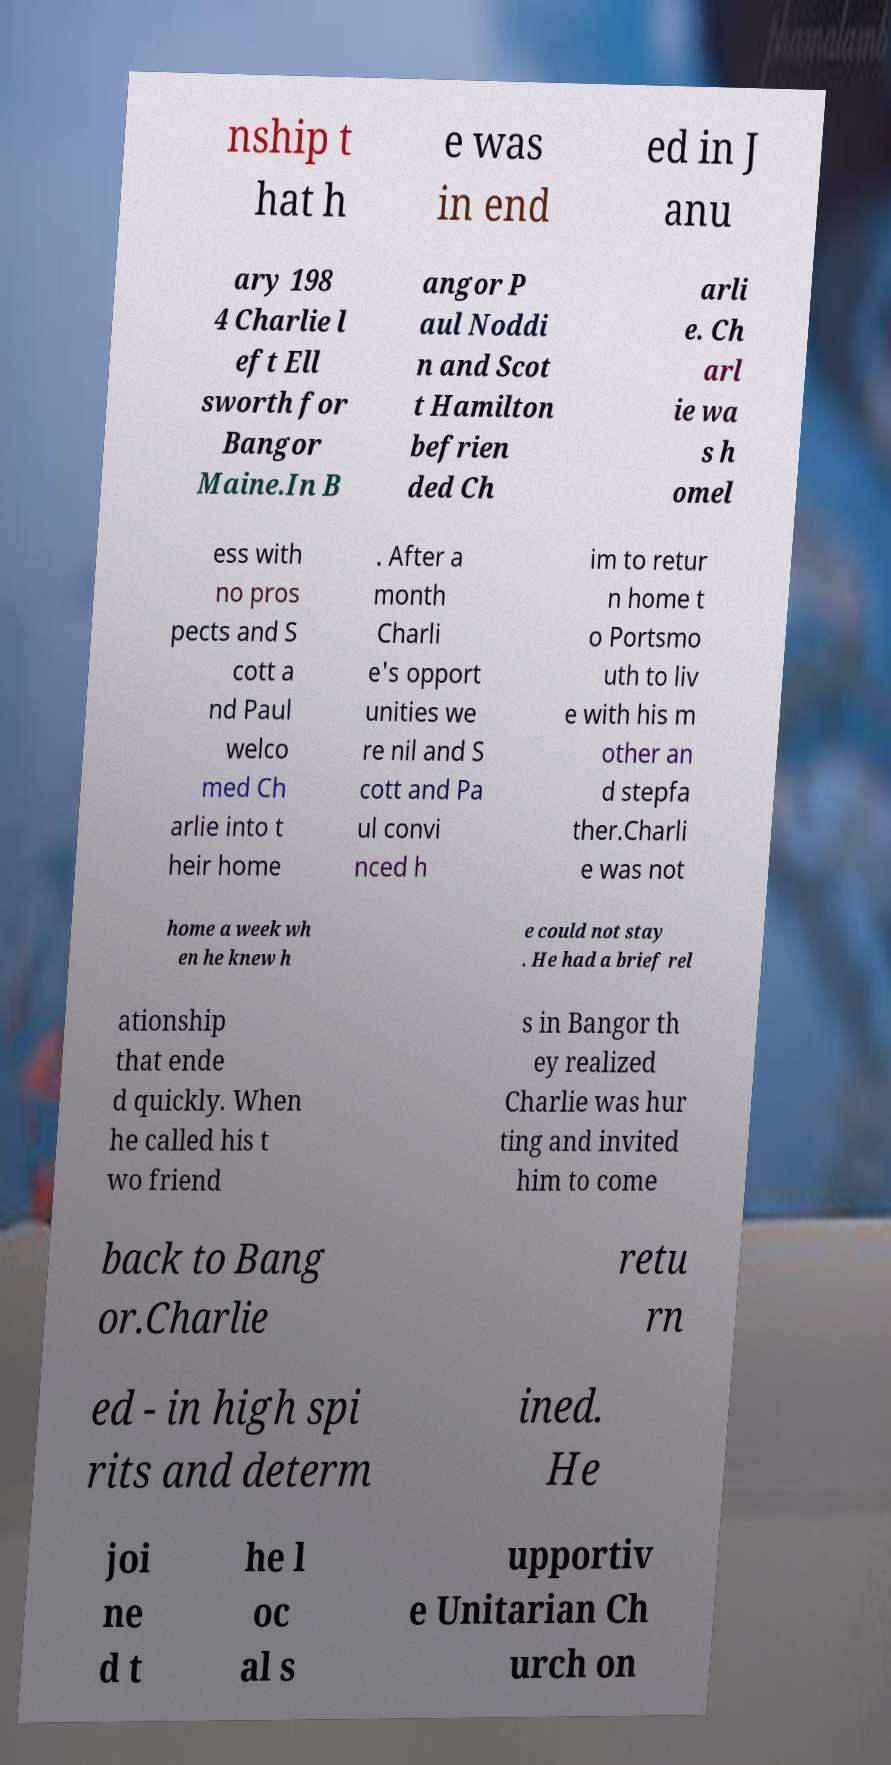Can you accurately transcribe the text from the provided image for me? nship t hat h e was in end ed in J anu ary 198 4 Charlie l eft Ell sworth for Bangor Maine.In B angor P aul Noddi n and Scot t Hamilton befrien ded Ch arli e. Ch arl ie wa s h omel ess with no pros pects and S cott a nd Paul welco med Ch arlie into t heir home . After a month Charli e's opport unities we re nil and S cott and Pa ul convi nced h im to retur n home t o Portsmo uth to liv e with his m other an d stepfa ther.Charli e was not home a week wh en he knew h e could not stay . He had a brief rel ationship that ende d quickly. When he called his t wo friend s in Bangor th ey realized Charlie was hur ting and invited him to come back to Bang or.Charlie retu rn ed - in high spi rits and determ ined. He joi ne d t he l oc al s upportiv e Unitarian Ch urch on 